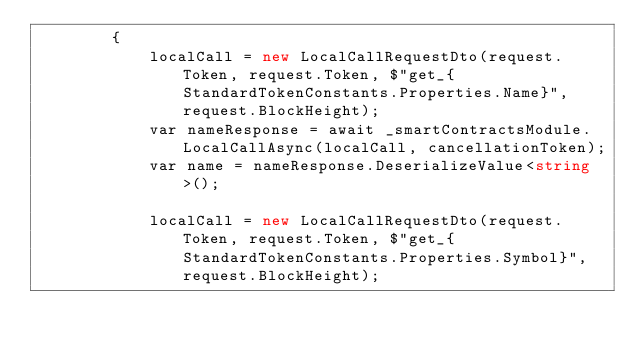<code> <loc_0><loc_0><loc_500><loc_500><_C#_>        {
            localCall = new LocalCallRequestDto(request.Token, request.Token, $"get_{StandardTokenConstants.Properties.Name}", request.BlockHeight);
            var nameResponse = await _smartContractsModule.LocalCallAsync(localCall, cancellationToken);
            var name = nameResponse.DeserializeValue<string>();

            localCall = new LocalCallRequestDto(request.Token, request.Token, $"get_{StandardTokenConstants.Properties.Symbol}", request.BlockHeight);</code> 